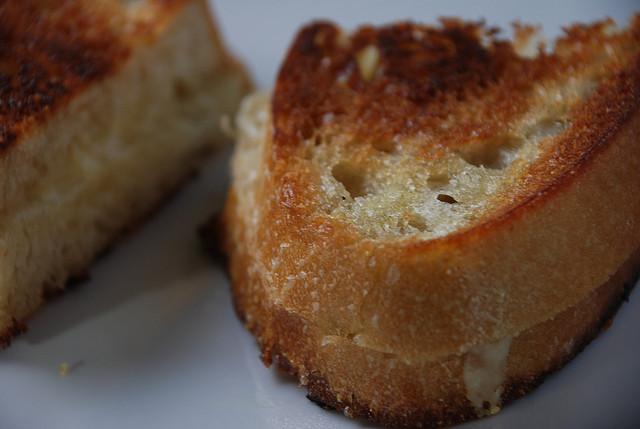What is this item?
Concise answer only. Bread. Is this food fresh or toasted?
Be succinct. Toasted. Is there a utensil present?
Concise answer only. No. What color is the bread?
Keep it brief. Brown. 